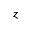<formula> <loc_0><loc_0><loc_500><loc_500>z</formula> 